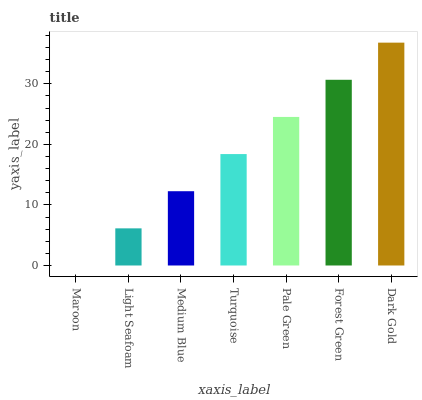Is Maroon the minimum?
Answer yes or no. Yes. Is Dark Gold the maximum?
Answer yes or no. Yes. Is Light Seafoam the minimum?
Answer yes or no. No. Is Light Seafoam the maximum?
Answer yes or no. No. Is Light Seafoam greater than Maroon?
Answer yes or no. Yes. Is Maroon less than Light Seafoam?
Answer yes or no. Yes. Is Maroon greater than Light Seafoam?
Answer yes or no. No. Is Light Seafoam less than Maroon?
Answer yes or no. No. Is Turquoise the high median?
Answer yes or no. Yes. Is Turquoise the low median?
Answer yes or no. Yes. Is Dark Gold the high median?
Answer yes or no. No. Is Dark Gold the low median?
Answer yes or no. No. 